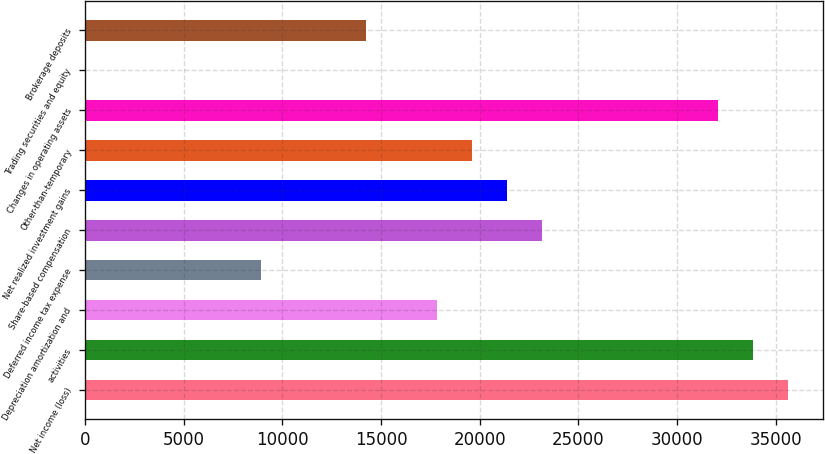Convert chart to OTSL. <chart><loc_0><loc_0><loc_500><loc_500><bar_chart><fcel>Net income (loss)<fcel>activities<fcel>Depreciation amortization and<fcel>Deferred income tax expense<fcel>Share-based compensation<fcel>Net realized investment gains<fcel>Other-than-temporary<fcel>Changes in operating assets<fcel>Trading securities and equity<fcel>Brokerage deposits<nl><fcel>35624<fcel>33843.1<fcel>17815<fcel>8910.5<fcel>23157.7<fcel>21376.8<fcel>19595.9<fcel>32062.2<fcel>6<fcel>14253.2<nl></chart> 